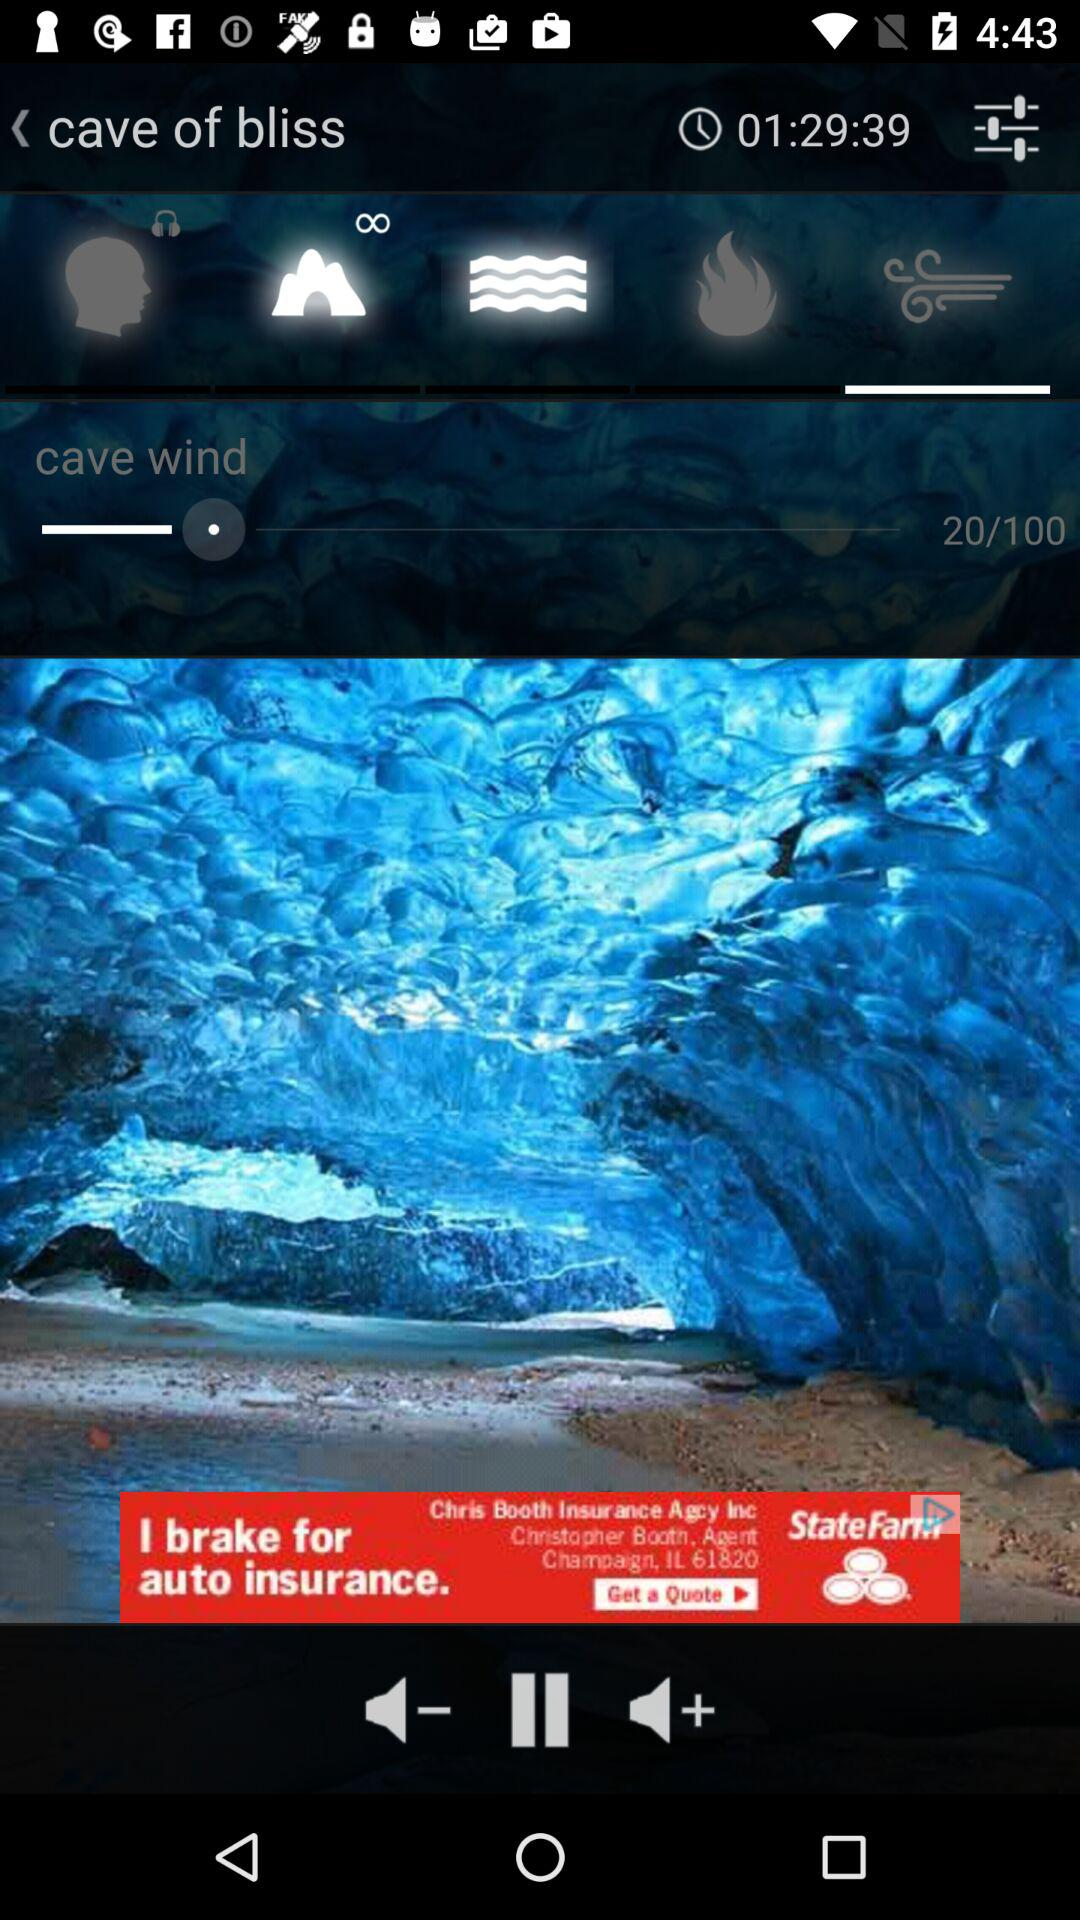What is the duration? The duration is 1 hour 29 minutes 39 seconds. 